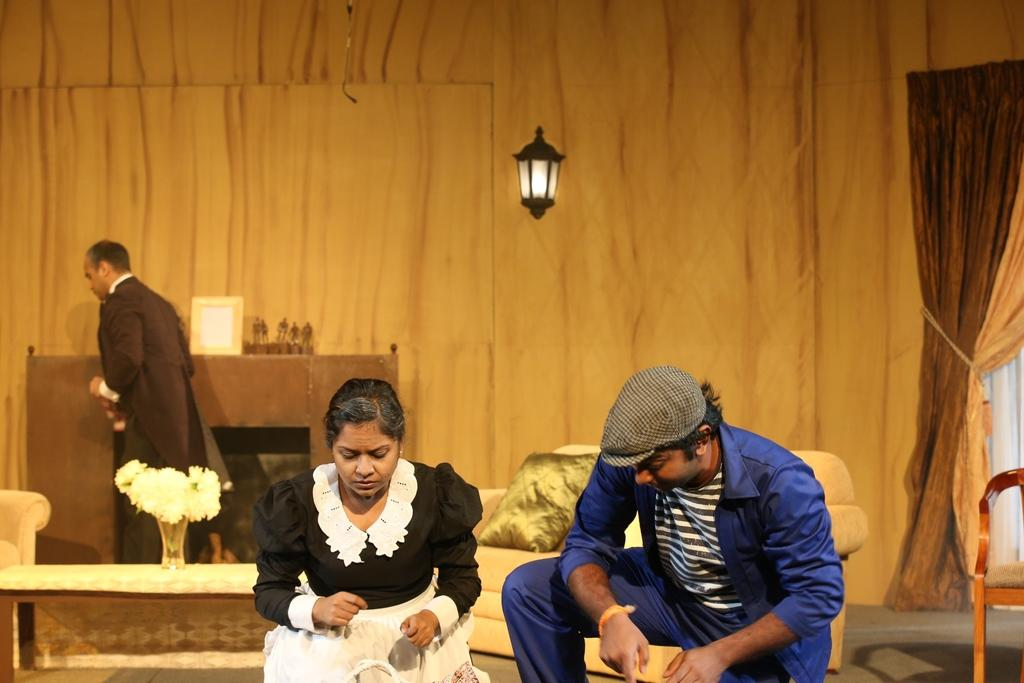How many people are in the image? There are three people in the image. What can be seen on the table in the image? There is a flower vase on a table in the image. What type of seating is present in the image? There is a sofa with pillows and a chair in the image. What type of window treatment is visible in the image? There are curtains in the image. What is visible in the background of the image? There is a wall visible in the background of the image. How many houses can be seen in the image? There are no houses visible in the image; only a wall is present in the background. What type of bird is perched on the sofa in the image? There is no bird present in the image; it only features three people, a flower vase, a sofa, pillows, a chair, curtains, and a wall in the background. 